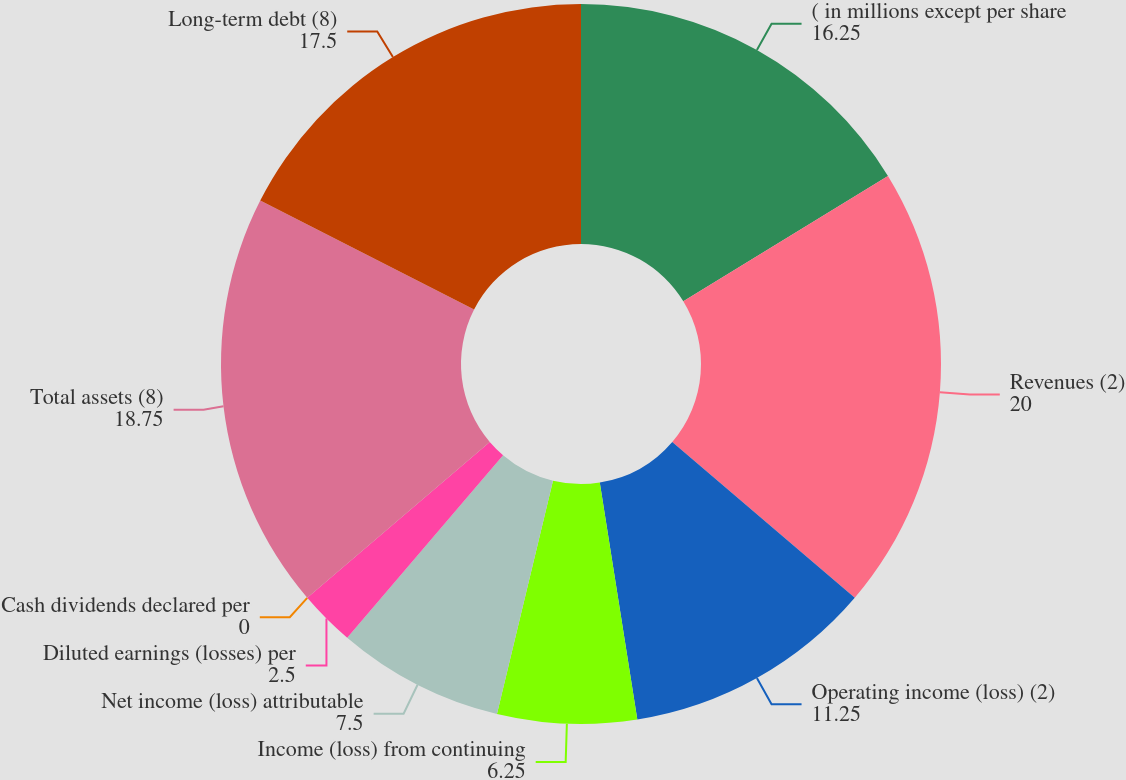Convert chart. <chart><loc_0><loc_0><loc_500><loc_500><pie_chart><fcel>( in millions except per share<fcel>Revenues (2)<fcel>Operating income (loss) (2)<fcel>Income (loss) from continuing<fcel>Net income (loss) attributable<fcel>Diluted earnings (losses) per<fcel>Cash dividends declared per<fcel>Total assets (8)<fcel>Long-term debt (8)<nl><fcel>16.25%<fcel>20.0%<fcel>11.25%<fcel>6.25%<fcel>7.5%<fcel>2.5%<fcel>0.0%<fcel>18.75%<fcel>17.5%<nl></chart> 